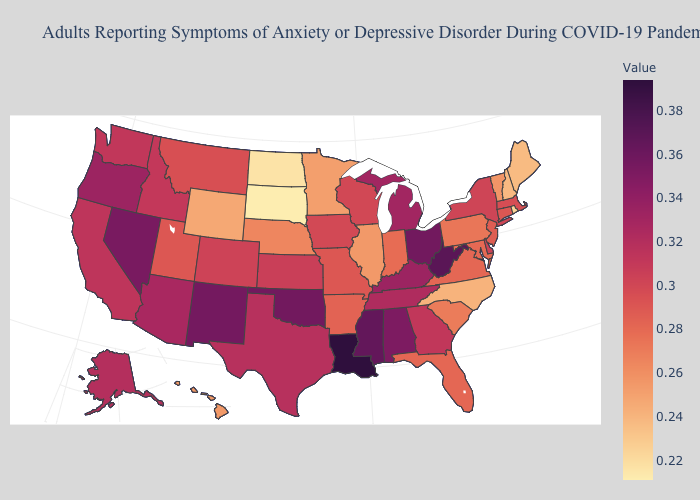Which states have the highest value in the USA?
Quick response, please. Louisiana. Does Rhode Island have the lowest value in the Northeast?
Keep it brief. Yes. Which states hav the highest value in the Northeast?
Concise answer only. New York. Which states hav the highest value in the MidWest?
Keep it brief. Ohio. Which states have the highest value in the USA?
Quick response, please. Louisiana. Does North Carolina have the highest value in the USA?
Be succinct. No. Among the states that border Indiana , does Illinois have the highest value?
Short answer required. No. Which states have the lowest value in the USA?
Short answer required. South Dakota. 